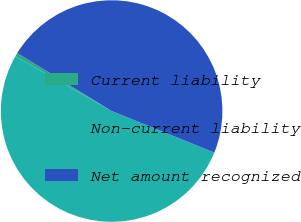<chart> <loc_0><loc_0><loc_500><loc_500><pie_chart><fcel>Current liability<fcel>Non-current liability<fcel>Net amount recognized<nl><fcel>0.53%<fcel>52.12%<fcel>47.35%<nl></chart> 